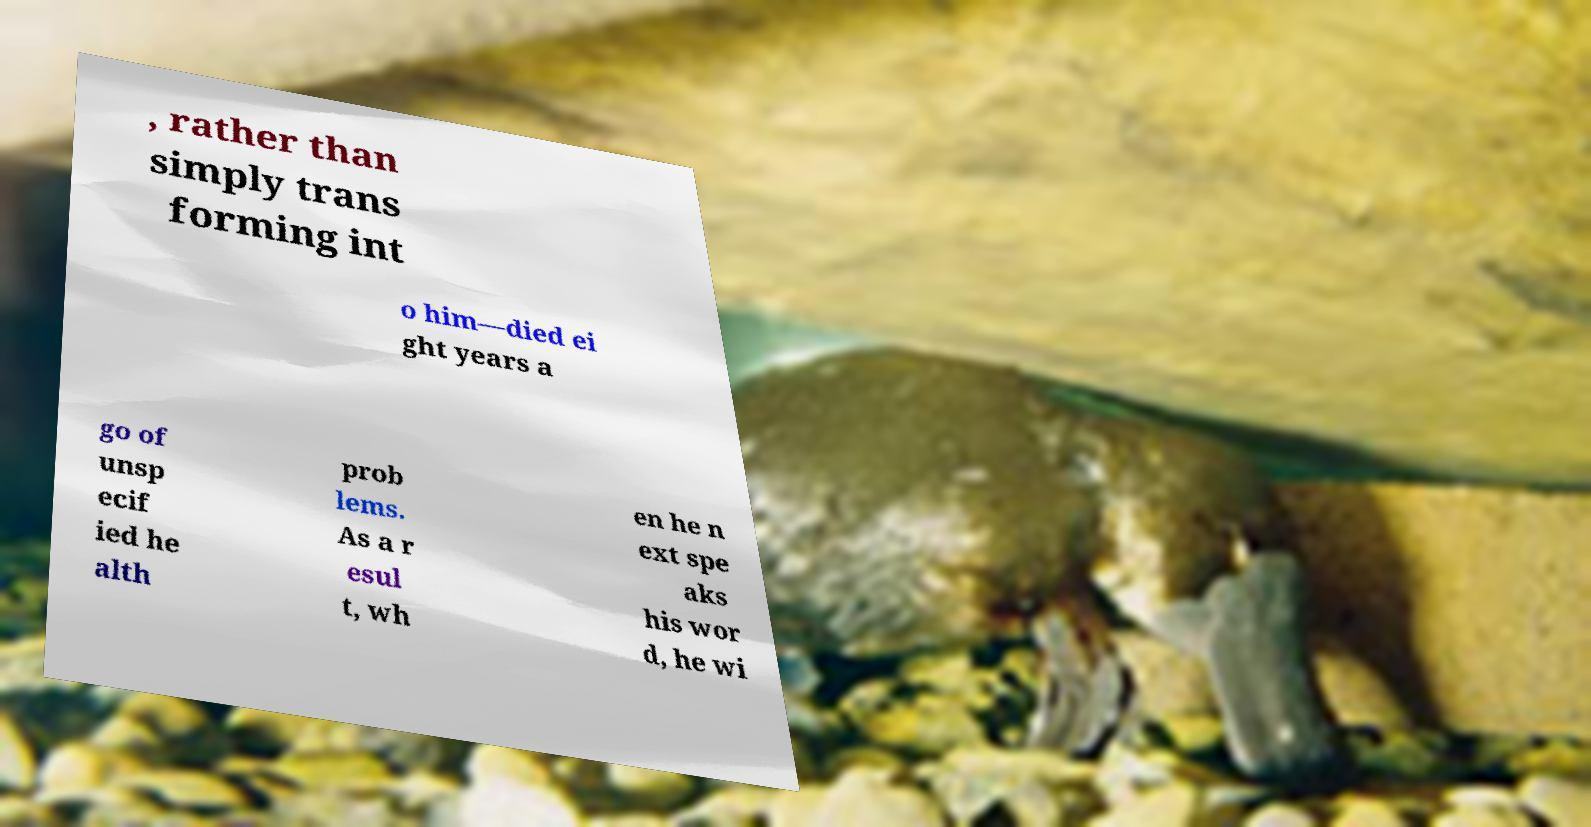Please identify and transcribe the text found in this image. , rather than simply trans forming int o him—died ei ght years a go of unsp ecif ied he alth prob lems. As a r esul t, wh en he n ext spe aks his wor d, he wi 